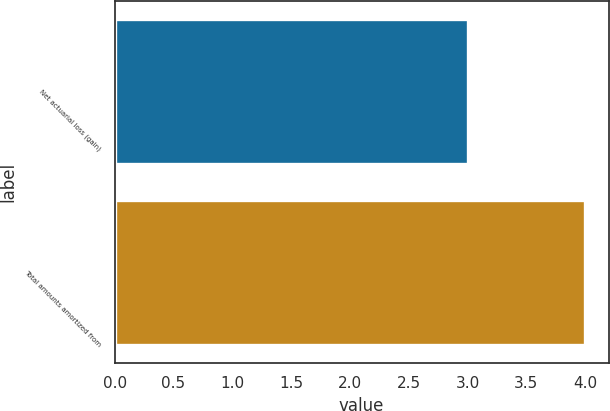Convert chart to OTSL. <chart><loc_0><loc_0><loc_500><loc_500><bar_chart><fcel>Net actuarial loss (gain)<fcel>Total amounts amortized from<nl><fcel>3<fcel>4<nl></chart> 